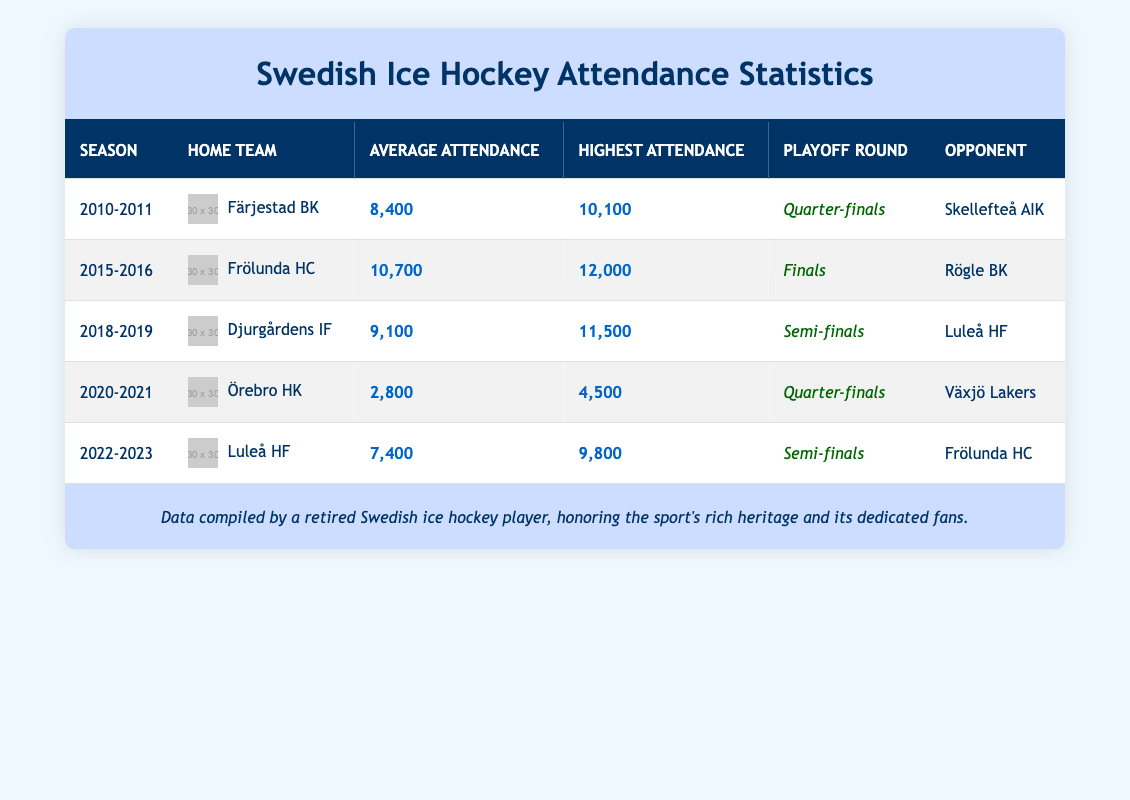What was the average attendance for the 2015-2016 season? The average attendance for the 2015-2016 season is found in the corresponding row for Frölunda HC, which shows an average attendance of 10,700.
Answer: 10,700 Which team had the highest attendance during the 2010-2011 season? In the 2010-2011 season, the highest attendance is listed under Färjestad BK, which had a highest attendance of 10,100.
Answer: Färjestad BK Is it true that Örebro HK had an average attendance of less than 5,000 in the 2020-2021 season? Looking at the 2020-2021 season row for Örebro HK, the average attendance is 2,800, which is indeed less than 5,000.
Answer: Yes How many times did teams have an average attendance greater than 9,000? By reviewing the average attendance figures, we see that Frölunda HC (10,700), Djurgårdens IF (9,100), and Färjestad BK (8,400) exceed 9,000, which totals to three instances.
Answer: 3 Which playoff round had the lowest recorded average attendance and what was the value? The lowest average attendance is found in the 2020-2021 season during the Quarter-finals, by Örebro HK, with an average attendance of 2,800.
Answer: Quarter-finals, 2,800 Was the highest attendance for the Semi-finals more than 10,000? The Semi-finals for Djurgårdens IF had a highest attendance of 11,500 and Luleå HF had a highest attendance of 9,800. Since 11,500 is greater than 10,000, this statement is true.
Answer: Yes What is the difference between the highest attendance of Frölunda HC in 2015-2016 and Luleå HF in 2022-2023? Frölunda HC's highest attendance in 2015-2016 was 12,000, while Luleå HF's highest attendance in 2022-2023 was 9,800. The difference is calculated as 12,000 - 9,800 = 2,200.
Answer: 2,200 Which home team had the highest average attendance in a playoff round? Frölunda HC has the highest average attendance of 10,700 in the Finals during the 2015-2016 season when comparing all other home teams and their respective playoff rounds.
Answer: Frölunda HC 